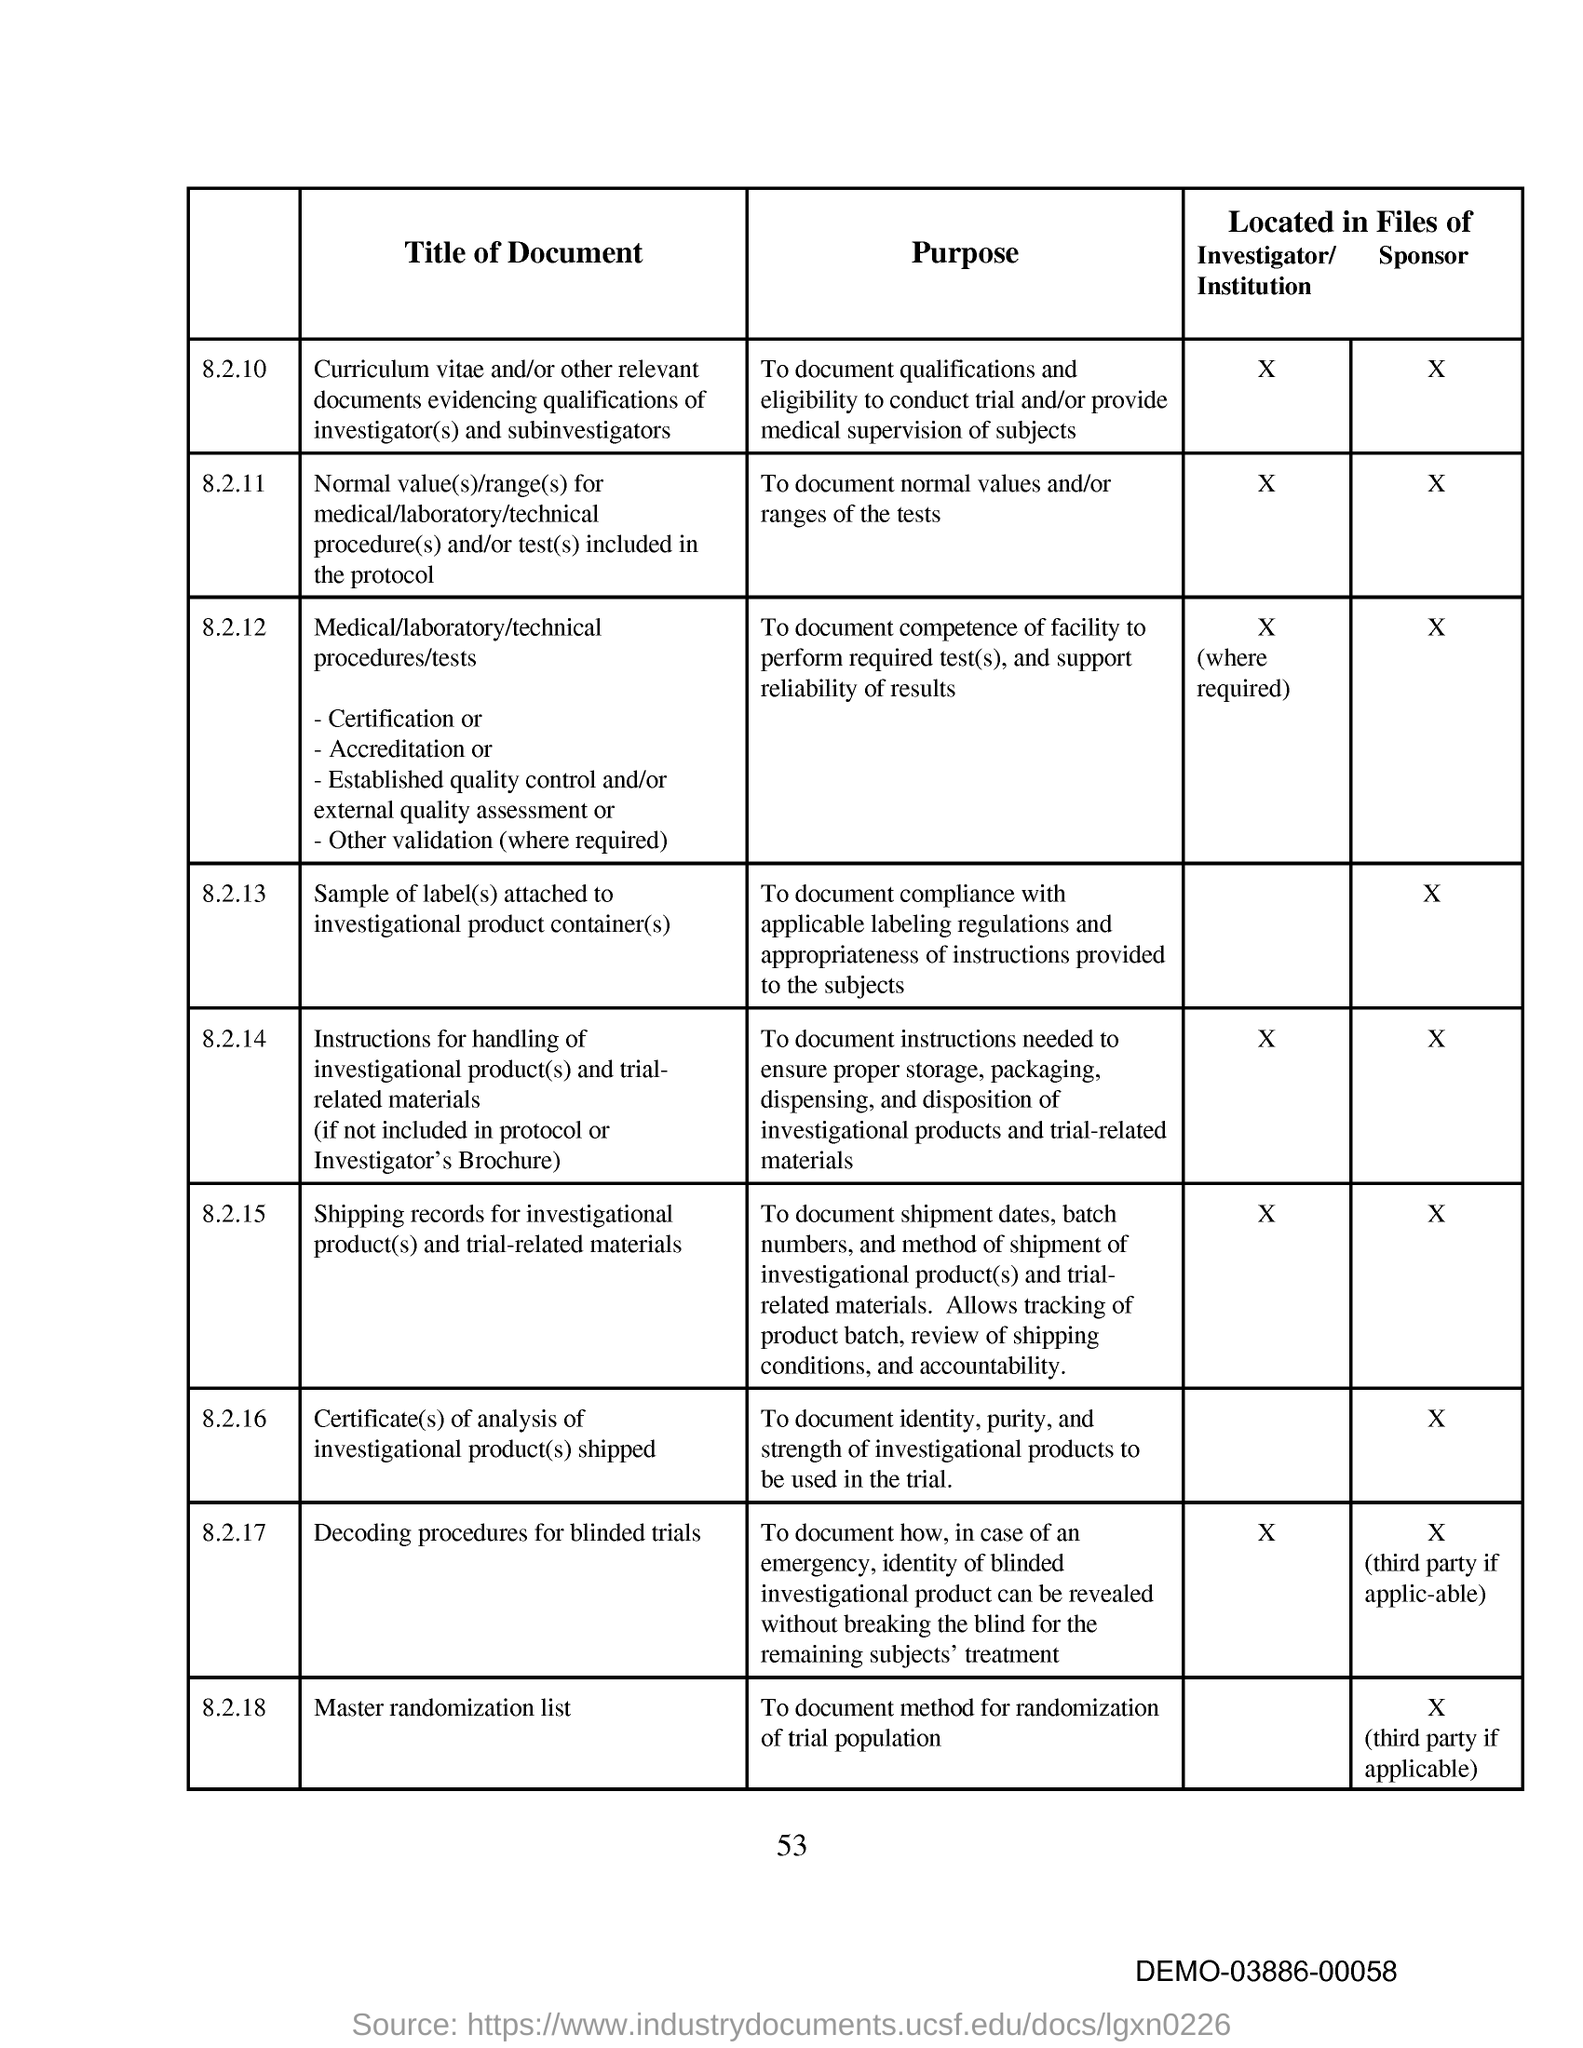What is the purpose of document under 8.2.11?
Give a very brief answer. To document normal values and/or ranges of the tests. 